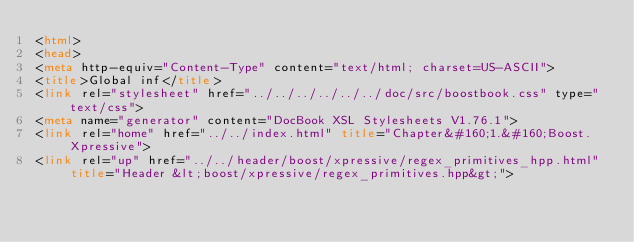<code> <loc_0><loc_0><loc_500><loc_500><_HTML_><html>
<head>
<meta http-equiv="Content-Type" content="text/html; charset=US-ASCII">
<title>Global inf</title>
<link rel="stylesheet" href="../../../../../../doc/src/boostbook.css" type="text/css">
<meta name="generator" content="DocBook XSL Stylesheets V1.76.1">
<link rel="home" href="../../index.html" title="Chapter&#160;1.&#160;Boost.Xpressive">
<link rel="up" href="../../header/boost/xpressive/regex_primitives_hpp.html" title="Header &lt;boost/xpressive/regex_primitives.hpp&gt;"></code> 